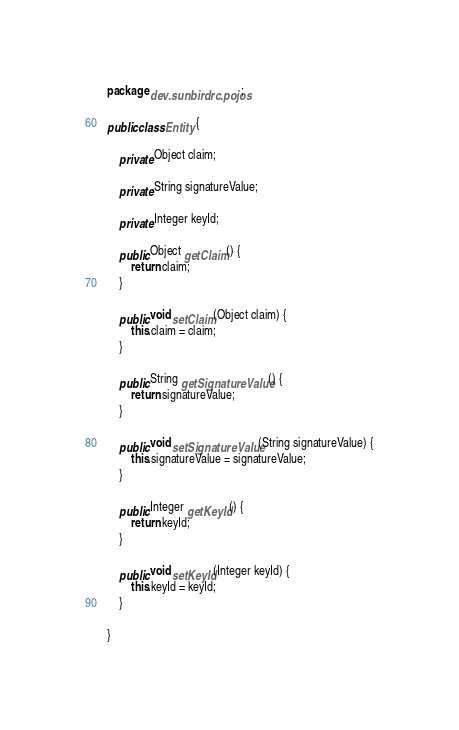<code> <loc_0><loc_0><loc_500><loc_500><_Java_>package dev.sunbirdrc.pojos;

public class Entity {

	private Object claim;

	private String signatureValue;

	private Integer keyId;

	public Object getClaim() {
		return claim;
	}

	public void setClaim(Object claim) {
		this.claim = claim;
	}

	public String getSignatureValue() {
		return signatureValue;
	}

	public void setSignatureValue(String signatureValue) {
		this.signatureValue = signatureValue;
	}

	public Integer getKeyId() {
		return keyId;
	}

	public void setKeyId(Integer keyId) {
		this.keyId = keyId;
	}

}
</code> 